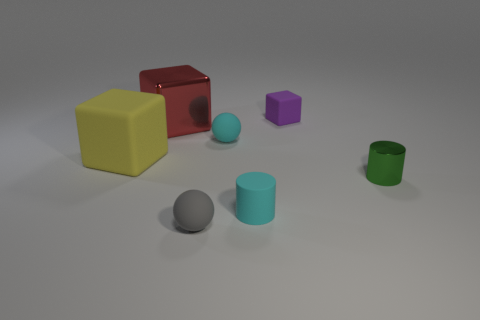Is there anything else that has the same material as the tiny cyan cylinder?
Ensure brevity in your answer.  Yes. The small matte thing behind the metallic thing on the left side of the matte block that is right of the large yellow cube is what shape?
Provide a succinct answer. Cube. How many other things are the same shape as the gray object?
Provide a short and direct response. 1. What is the color of the rubber cylinder that is the same size as the green object?
Your answer should be compact. Cyan. What number of cylinders are either large yellow matte things or big brown rubber things?
Your answer should be very brief. 0. How many yellow objects are there?
Your response must be concise. 1. Do the big metallic object and the small cyan object in front of the big matte object have the same shape?
Your answer should be very brief. No. There is a thing that is the same color as the small matte cylinder; what is its size?
Your response must be concise. Small. What number of objects are big blue metal things or tiny green cylinders?
Keep it short and to the point. 1. There is a object behind the metallic thing that is behind the large matte thing; what shape is it?
Ensure brevity in your answer.  Cube. 